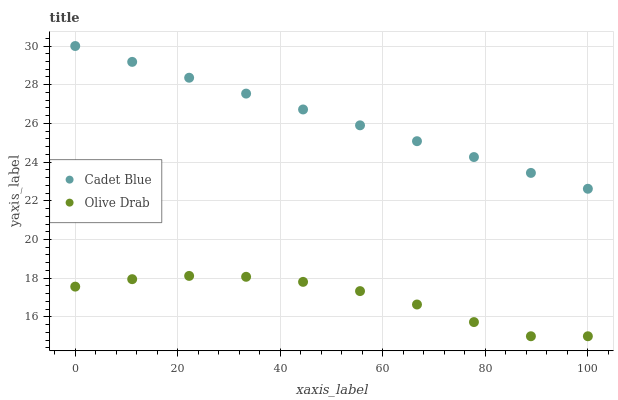Does Olive Drab have the minimum area under the curve?
Answer yes or no. Yes. Does Cadet Blue have the maximum area under the curve?
Answer yes or no. Yes. Does Olive Drab have the maximum area under the curve?
Answer yes or no. No. Is Cadet Blue the smoothest?
Answer yes or no. Yes. Is Olive Drab the roughest?
Answer yes or no. Yes. Is Olive Drab the smoothest?
Answer yes or no. No. Does Olive Drab have the lowest value?
Answer yes or no. Yes. Does Cadet Blue have the highest value?
Answer yes or no. Yes. Does Olive Drab have the highest value?
Answer yes or no. No. Is Olive Drab less than Cadet Blue?
Answer yes or no. Yes. Is Cadet Blue greater than Olive Drab?
Answer yes or no. Yes. Does Olive Drab intersect Cadet Blue?
Answer yes or no. No. 